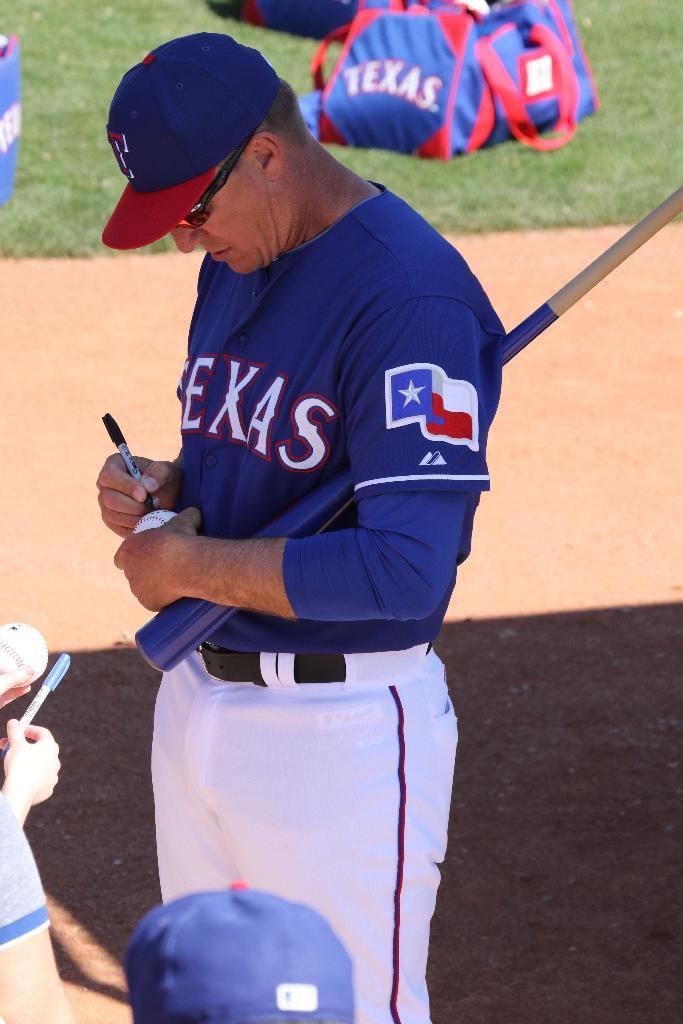<image>
Write a terse but informative summary of the picture. A baseball player wearing a blue jersey that says Texans across the front signing a baseball. 